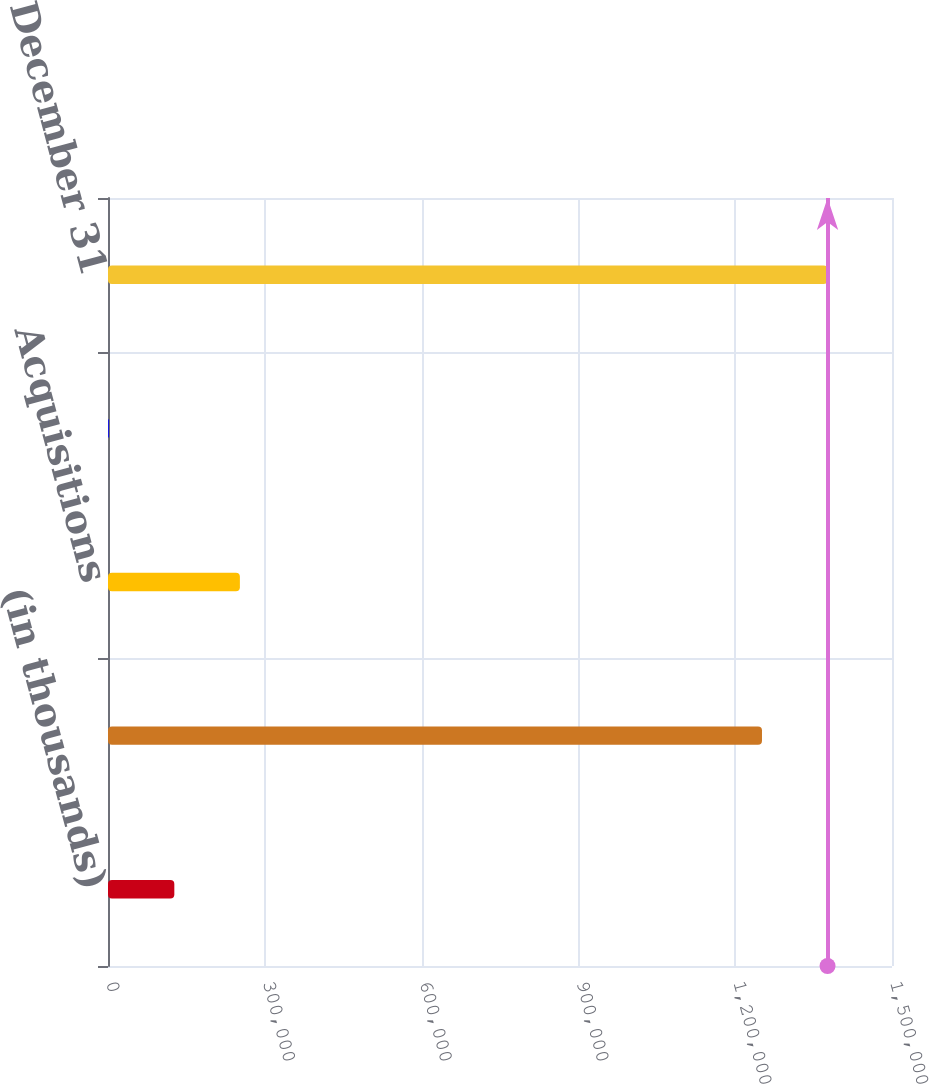Convert chart to OTSL. <chart><loc_0><loc_0><loc_500><loc_500><bar_chart><fcel>(in thousands)<fcel>Beginning balance - January 1<fcel>Acquisitions<fcel>Currency translation and other<fcel>Ending balance - December 31<nl><fcel>126902<fcel>1.25125e+06<fcel>252324<fcel>1479<fcel>1.37667e+06<nl></chart> 